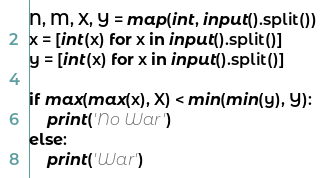Convert code to text. <code><loc_0><loc_0><loc_500><loc_500><_Python_>N, M, X, Y = map(int, input().split())
x = [int(x) for x in input().split()]
y = [int(x) for x in input().split()]

if max(max(x), X) < min(min(y), Y):
    print('No War')
else:
    print('War')
</code> 